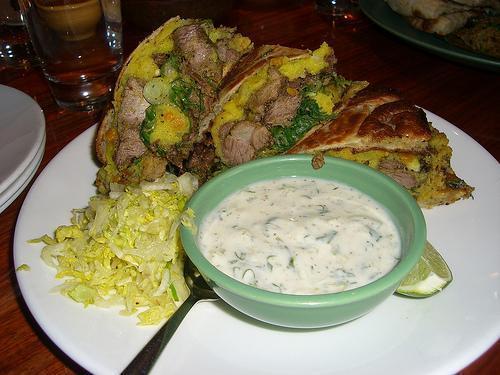How many utensils are on the plate?
Give a very brief answer. 1. 